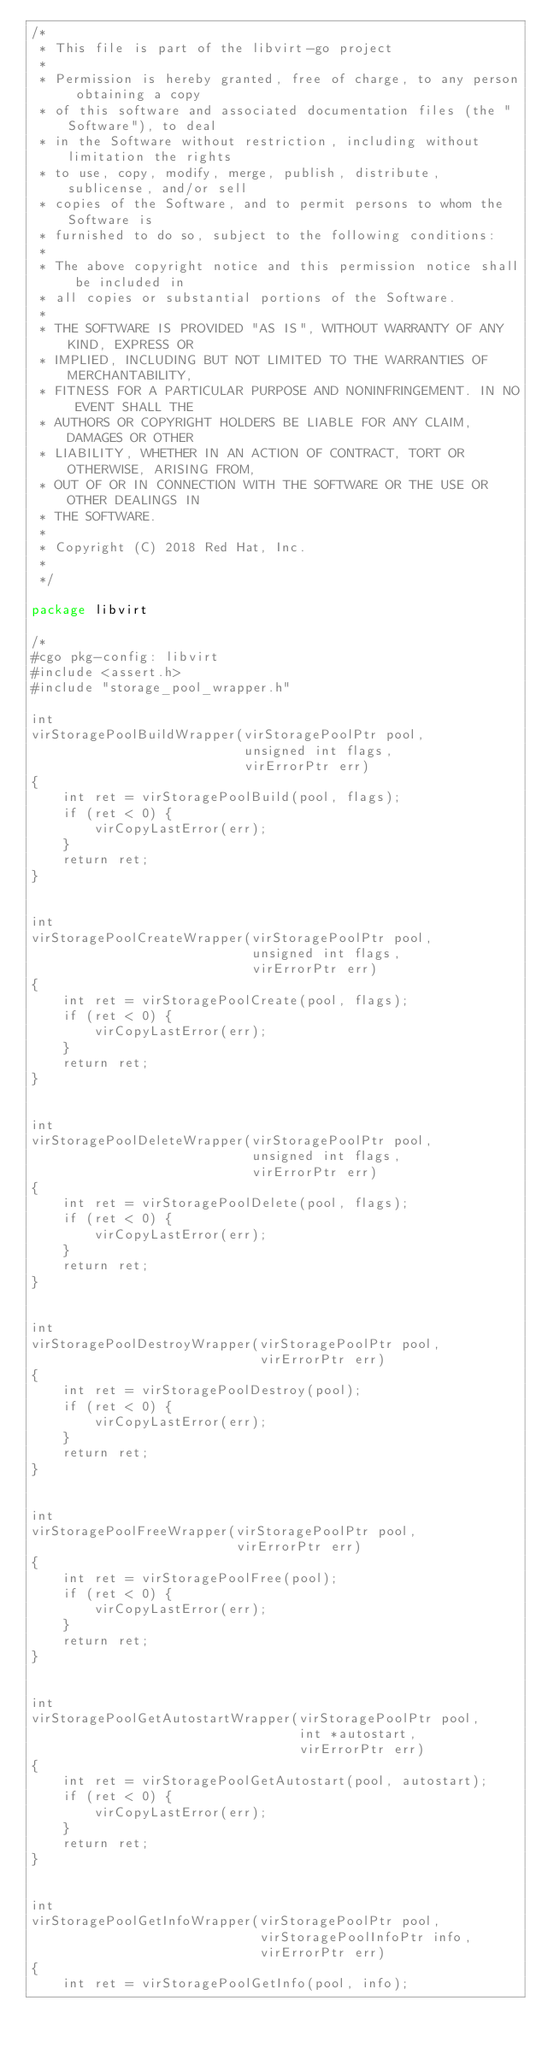Convert code to text. <code><loc_0><loc_0><loc_500><loc_500><_Go_>/*
 * This file is part of the libvirt-go project
 *
 * Permission is hereby granted, free of charge, to any person obtaining a copy
 * of this software and associated documentation files (the "Software"), to deal
 * in the Software without restriction, including without limitation the rights
 * to use, copy, modify, merge, publish, distribute, sublicense, and/or sell
 * copies of the Software, and to permit persons to whom the Software is
 * furnished to do so, subject to the following conditions:
 *
 * The above copyright notice and this permission notice shall be included in
 * all copies or substantial portions of the Software.
 *
 * THE SOFTWARE IS PROVIDED "AS IS", WITHOUT WARRANTY OF ANY KIND, EXPRESS OR
 * IMPLIED, INCLUDING BUT NOT LIMITED TO THE WARRANTIES OF MERCHANTABILITY,
 * FITNESS FOR A PARTICULAR PURPOSE AND NONINFRINGEMENT. IN NO EVENT SHALL THE
 * AUTHORS OR COPYRIGHT HOLDERS BE LIABLE FOR ANY CLAIM, DAMAGES OR OTHER
 * LIABILITY, WHETHER IN AN ACTION OF CONTRACT, TORT OR OTHERWISE, ARISING FROM,
 * OUT OF OR IN CONNECTION WITH THE SOFTWARE OR THE USE OR OTHER DEALINGS IN
 * THE SOFTWARE.
 *
 * Copyright (C) 2018 Red Hat, Inc.
 *
 */

package libvirt

/*
#cgo pkg-config: libvirt
#include <assert.h>
#include "storage_pool_wrapper.h"

int
virStoragePoolBuildWrapper(virStoragePoolPtr pool,
                           unsigned int flags,
                           virErrorPtr err)
{
    int ret = virStoragePoolBuild(pool, flags);
    if (ret < 0) {
        virCopyLastError(err);
    }
    return ret;
}


int
virStoragePoolCreateWrapper(virStoragePoolPtr pool,
                            unsigned int flags,
                            virErrorPtr err)
{
    int ret = virStoragePoolCreate(pool, flags);
    if (ret < 0) {
        virCopyLastError(err);
    }
    return ret;
}


int
virStoragePoolDeleteWrapper(virStoragePoolPtr pool,
                            unsigned int flags,
                            virErrorPtr err)
{
    int ret = virStoragePoolDelete(pool, flags);
    if (ret < 0) {
        virCopyLastError(err);
    }
    return ret;
}


int
virStoragePoolDestroyWrapper(virStoragePoolPtr pool,
                             virErrorPtr err)
{
    int ret = virStoragePoolDestroy(pool);
    if (ret < 0) {
        virCopyLastError(err);
    }
    return ret;
}


int
virStoragePoolFreeWrapper(virStoragePoolPtr pool,
                          virErrorPtr err)
{
    int ret = virStoragePoolFree(pool);
    if (ret < 0) {
        virCopyLastError(err);
    }
    return ret;
}


int
virStoragePoolGetAutostartWrapper(virStoragePoolPtr pool,
                                  int *autostart,
                                  virErrorPtr err)
{
    int ret = virStoragePoolGetAutostart(pool, autostart);
    if (ret < 0) {
        virCopyLastError(err);
    }
    return ret;
}


int
virStoragePoolGetInfoWrapper(virStoragePoolPtr pool,
                             virStoragePoolInfoPtr info,
                             virErrorPtr err)
{
    int ret = virStoragePoolGetInfo(pool, info);</code> 